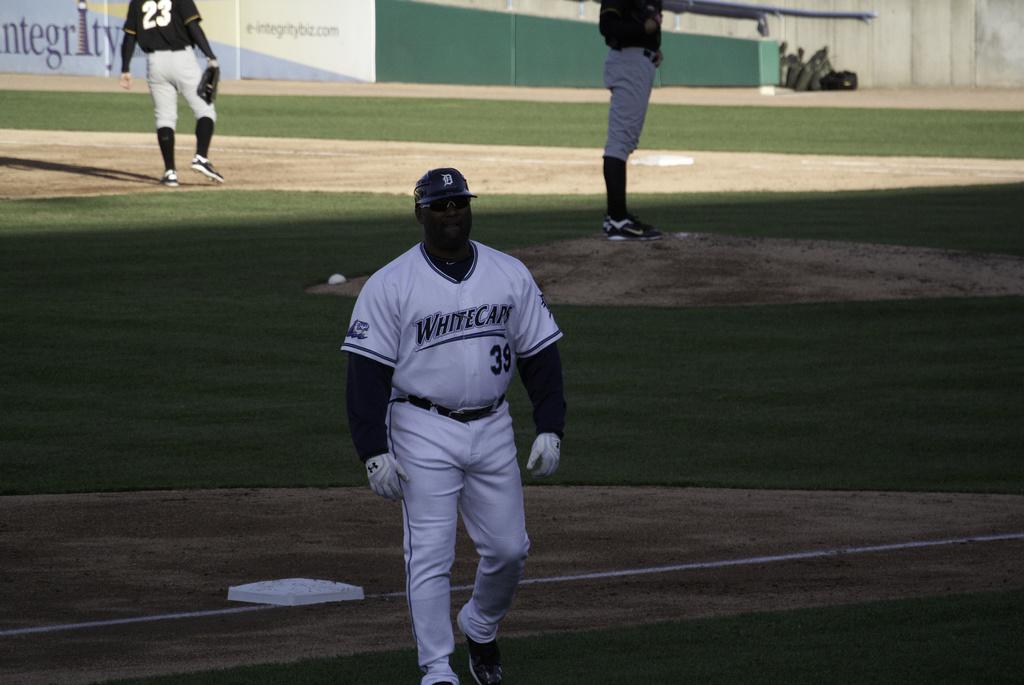What team does the man play for?
Provide a short and direct response. Whitecaps. 